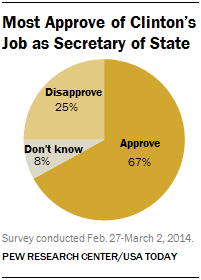Draw attention to some important aspects in this diagram. The result of taking the sum of the two smallest segments and multiplying it by 2, when compared to the largest segment, must be less than or equal to the largest segment. The largest segment is orange in color. 